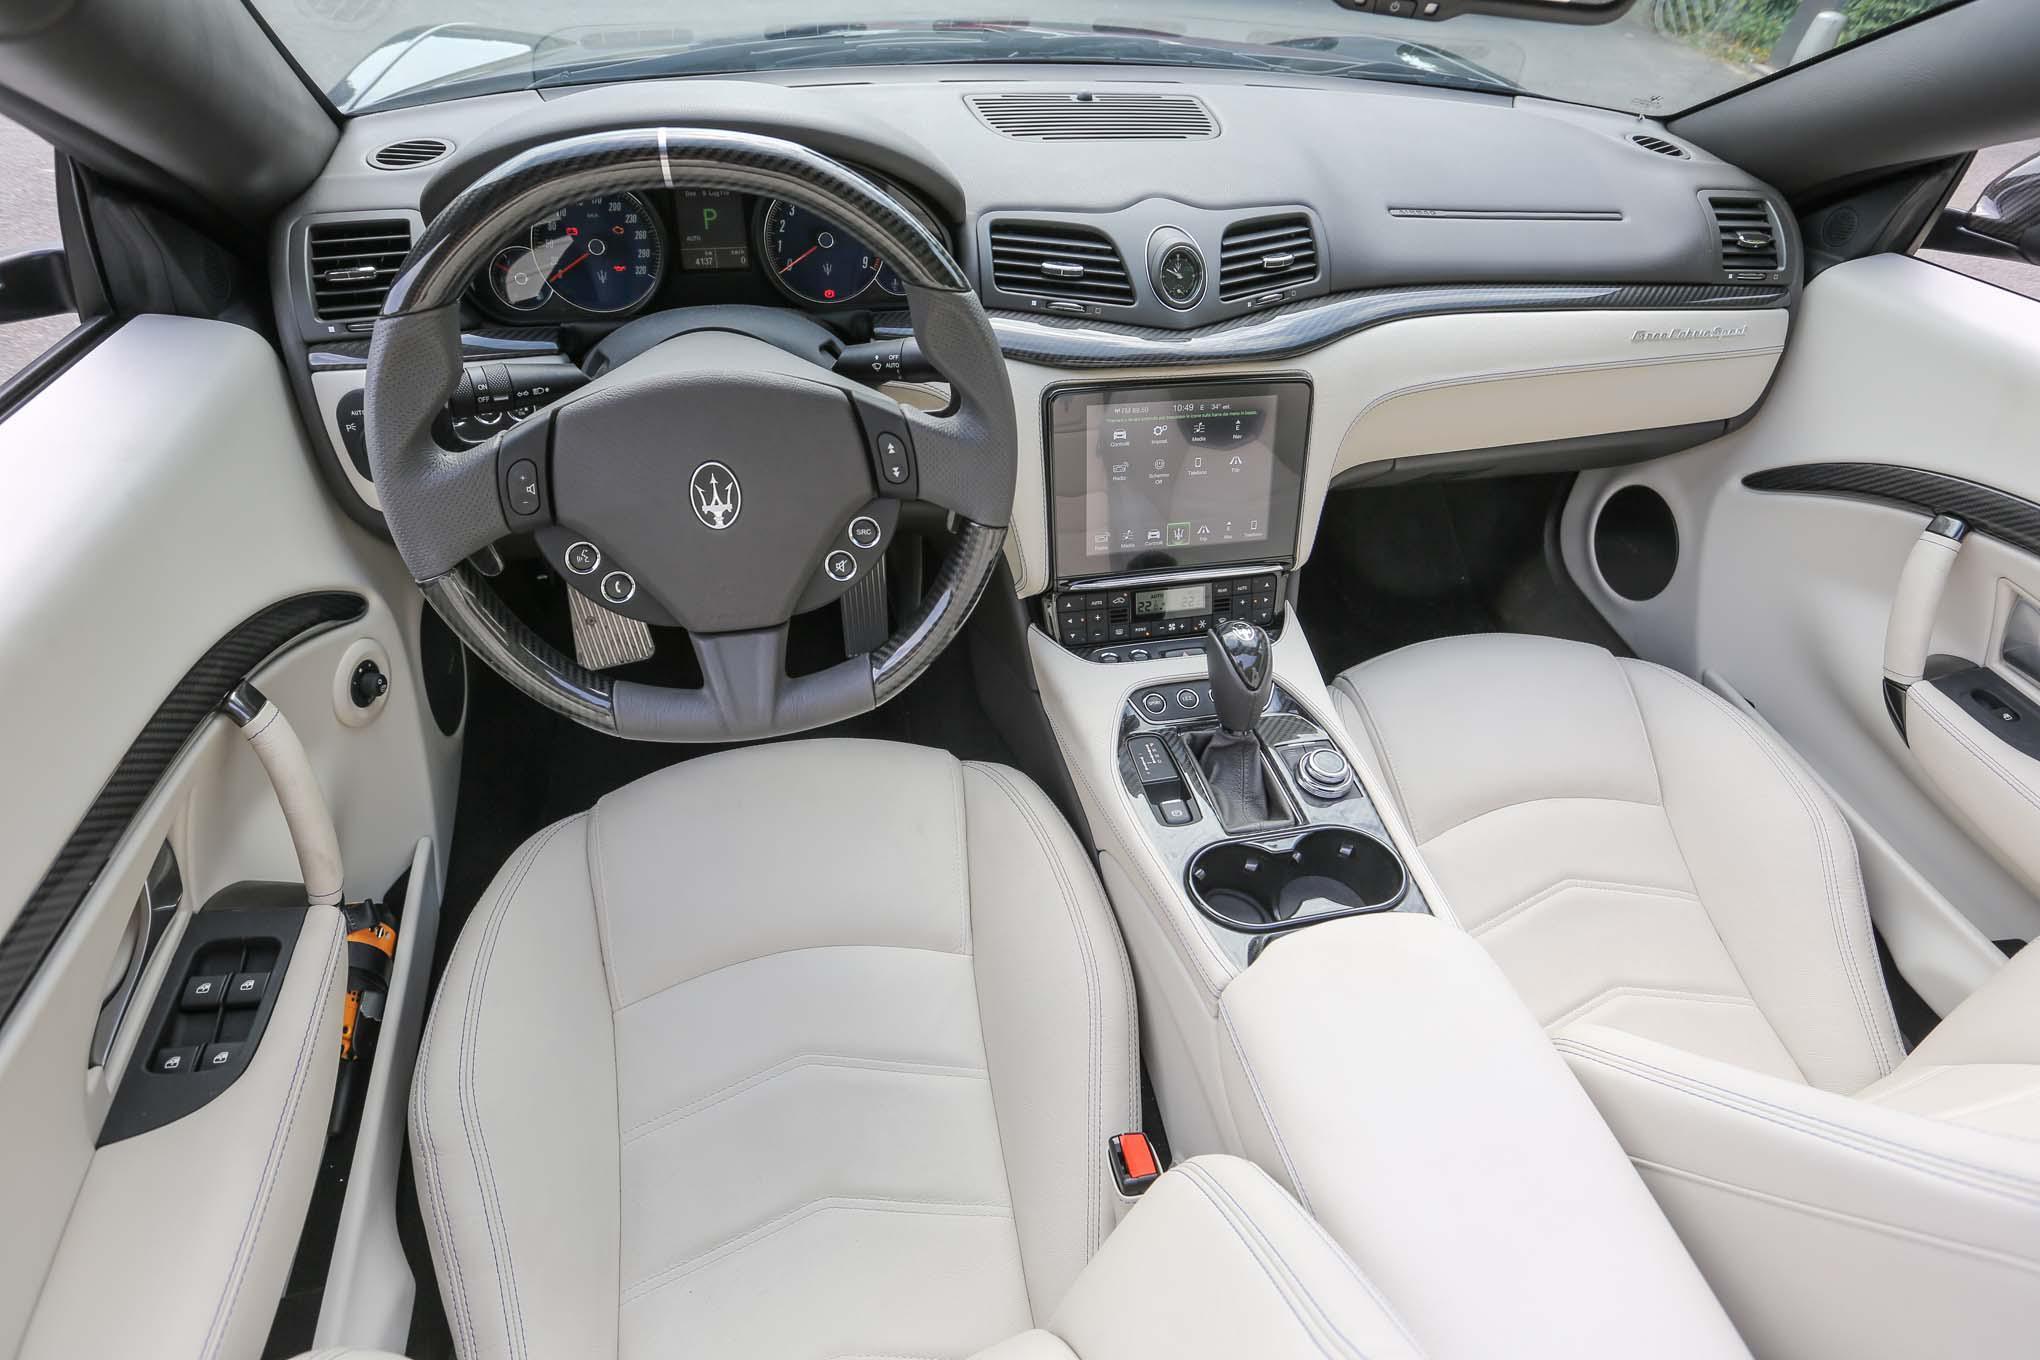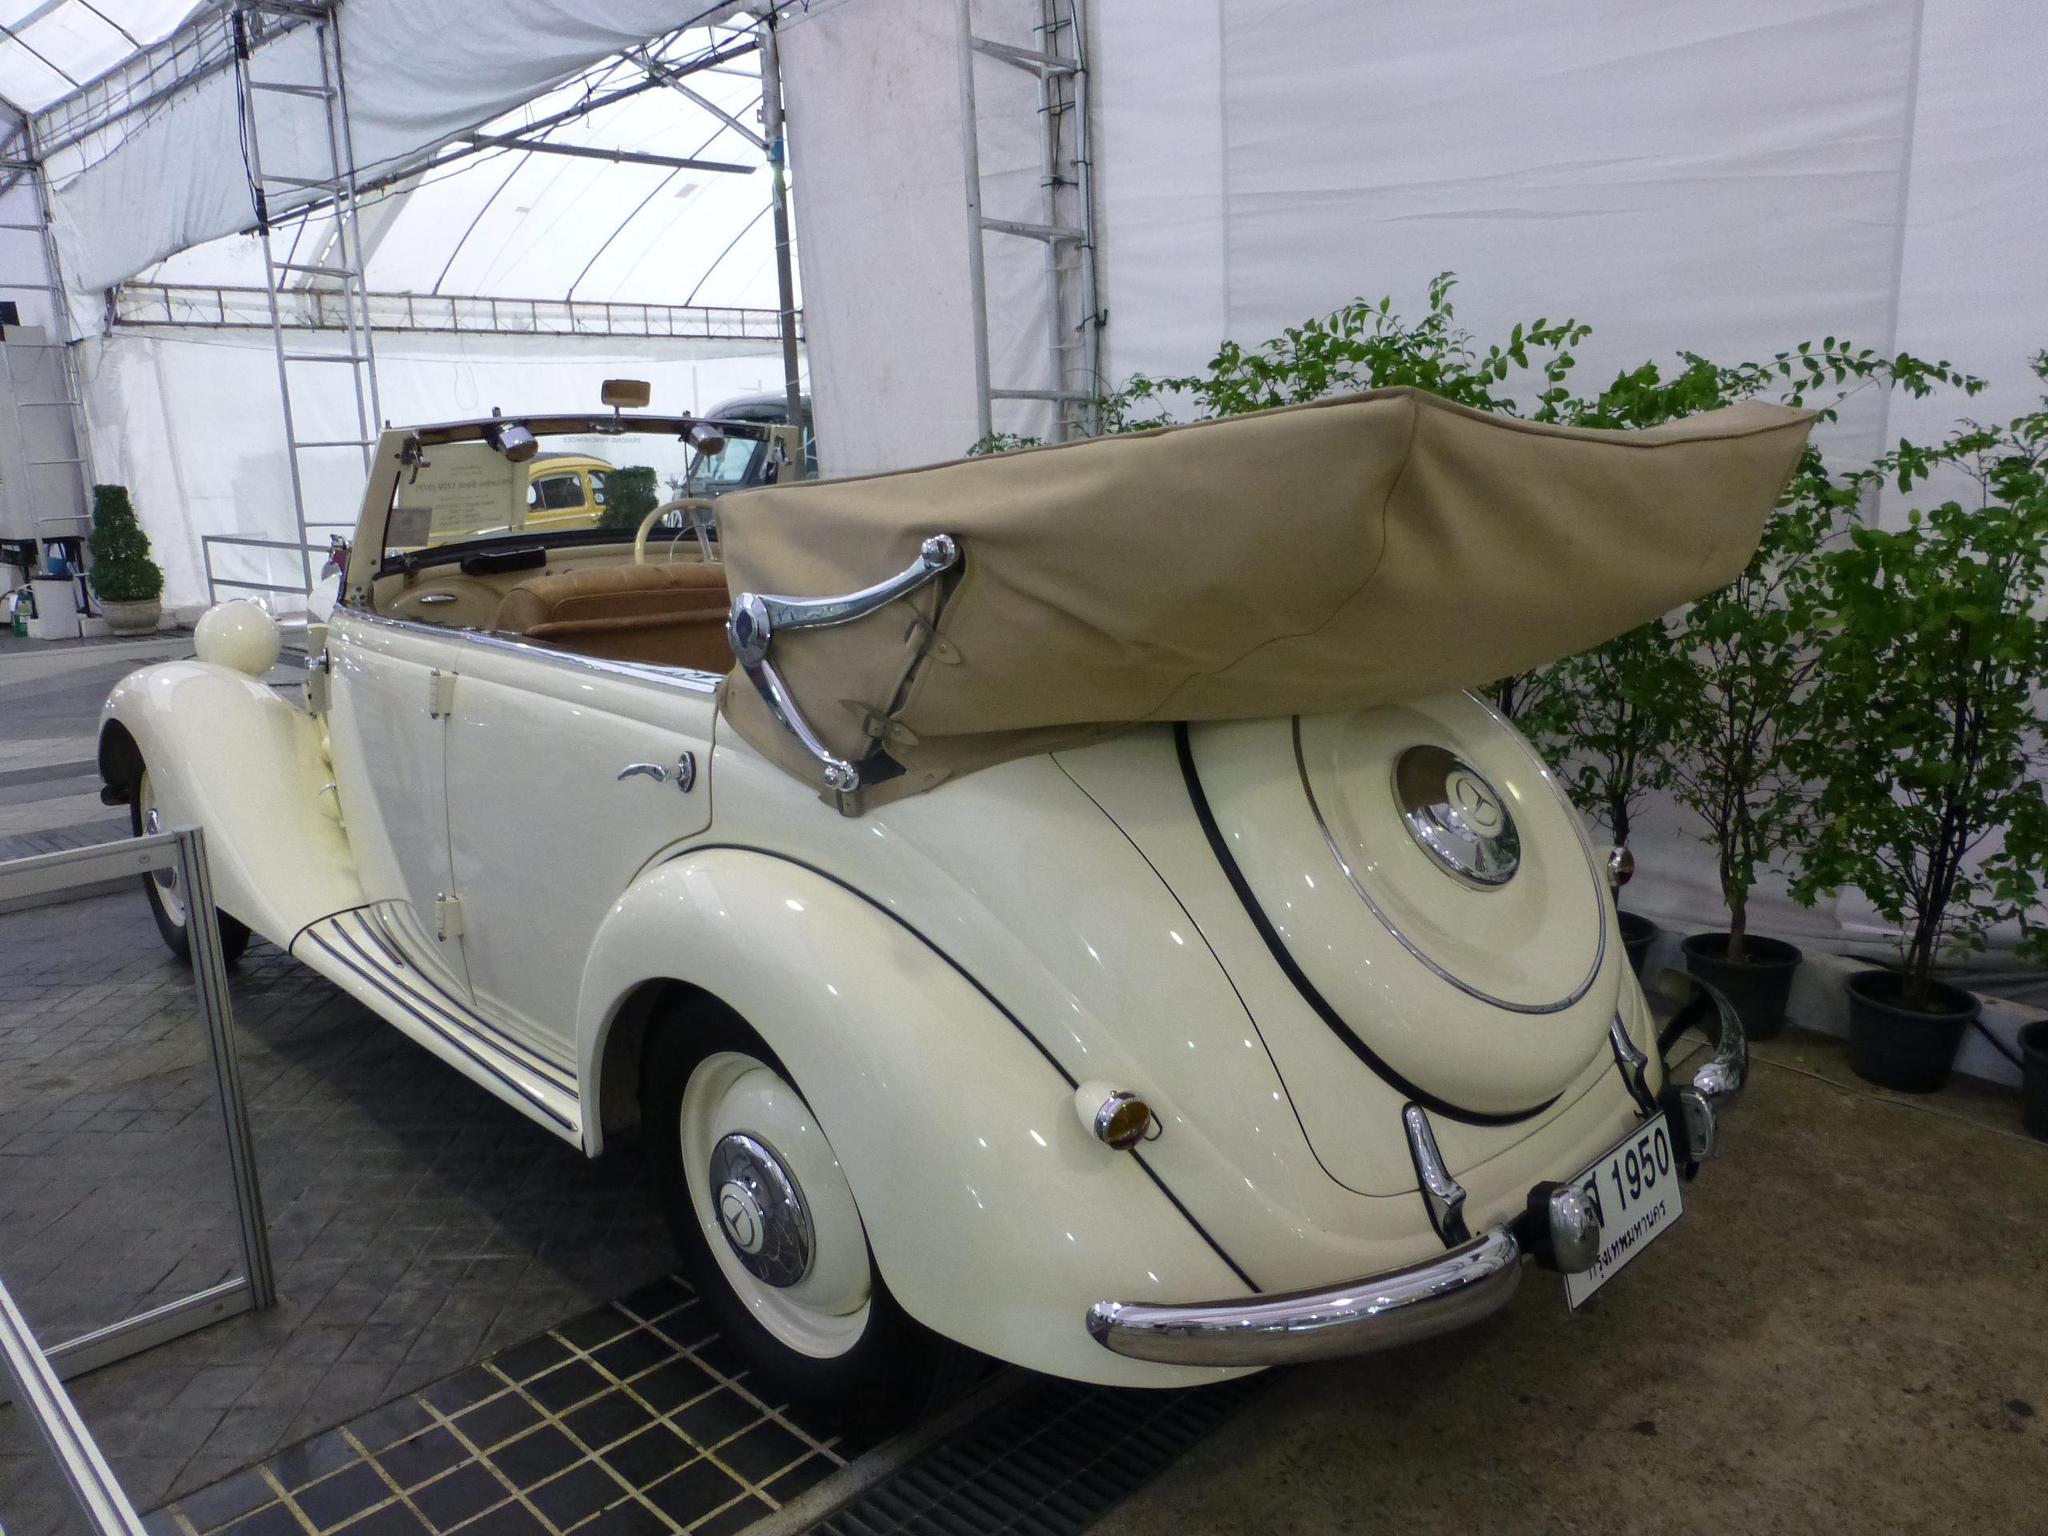The first image is the image on the left, the second image is the image on the right. Examine the images to the left and right. Is the description "One image shows white upholstered front seats and a darker steering wheel in a convertible car's interior, and the other image shows the folded soft top at the rear of the vehicle." accurate? Answer yes or no. Yes. The first image is the image on the left, the second image is the image on the right. Analyze the images presented: Is the assertion "The black top of the car is rolled down in one of the images." valid? Answer yes or no. No. 